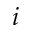<formula> <loc_0><loc_0><loc_500><loc_500>i</formula> 